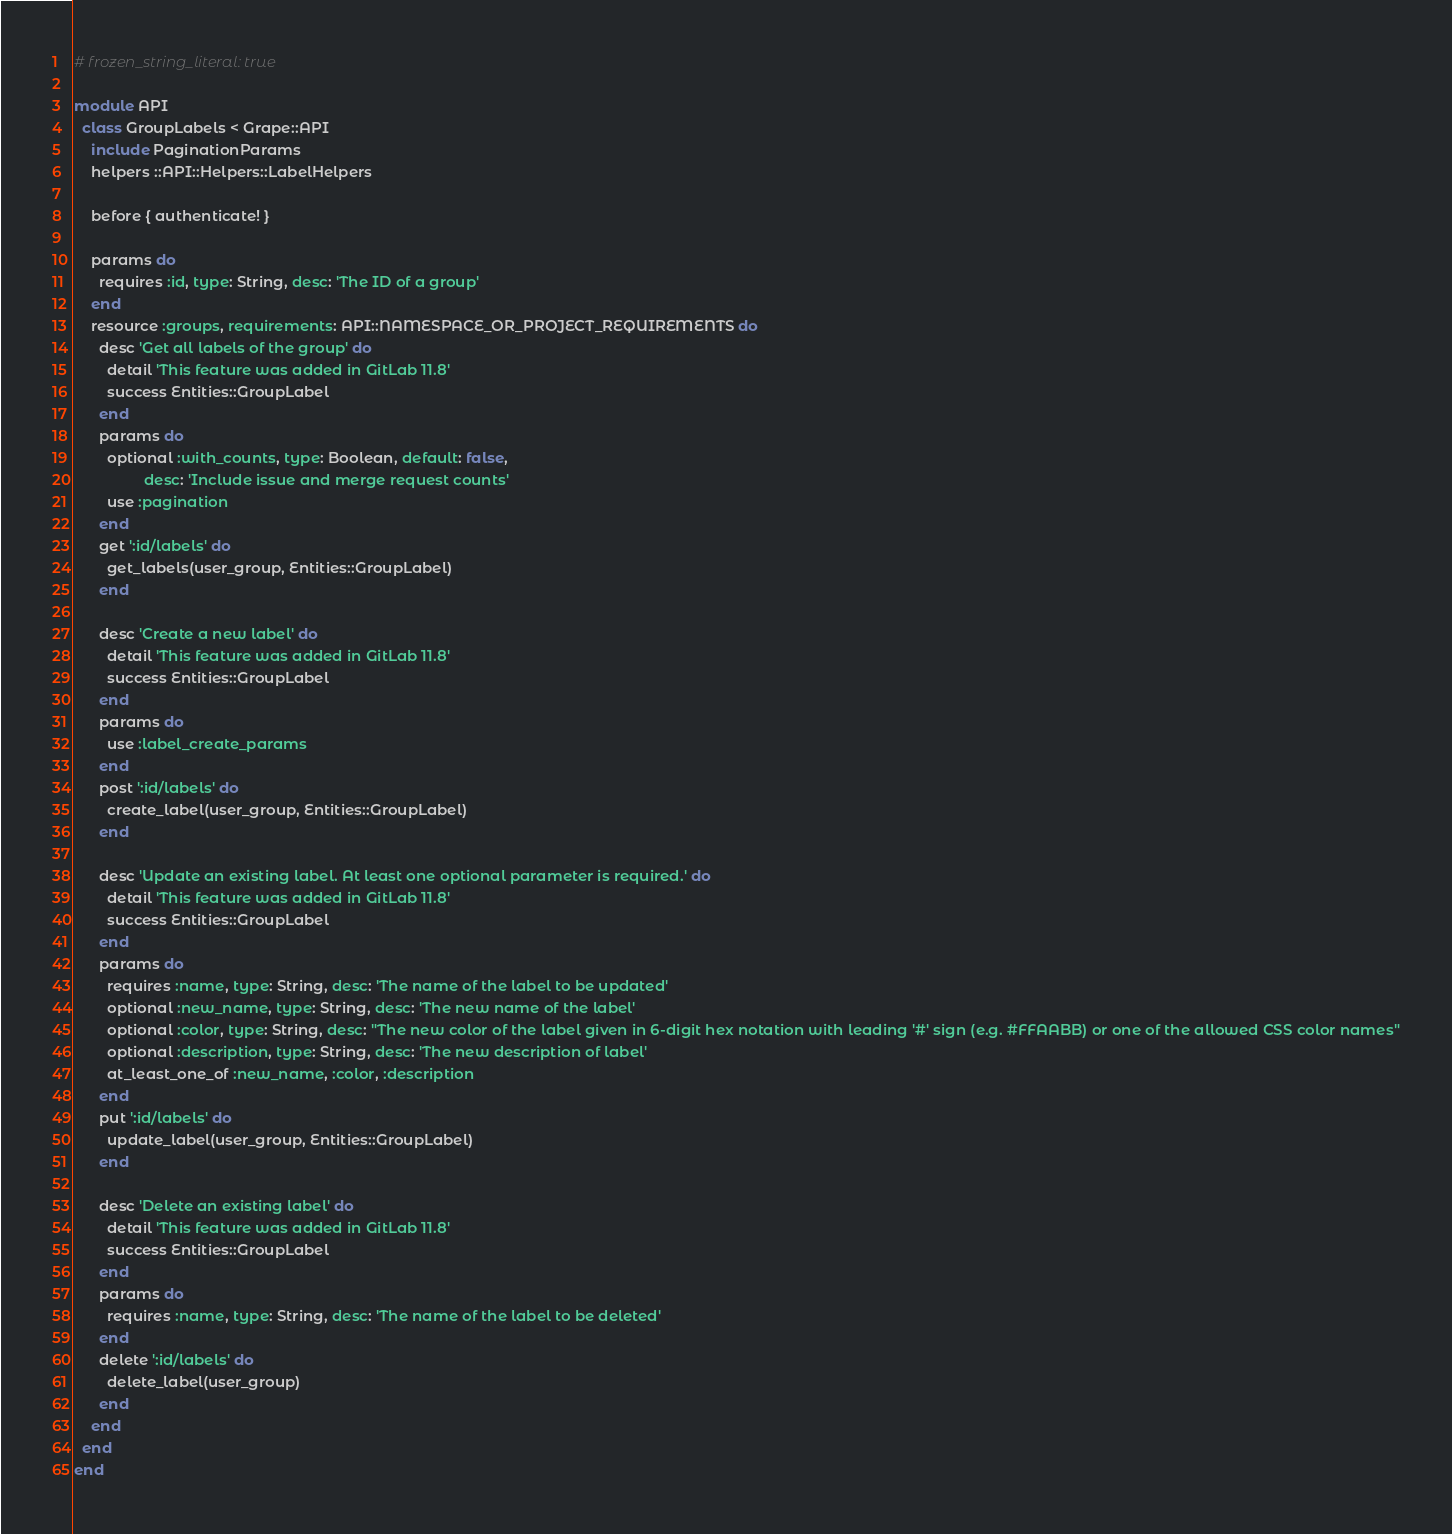<code> <loc_0><loc_0><loc_500><loc_500><_Ruby_># frozen_string_literal: true

module API
  class GroupLabels < Grape::API
    include PaginationParams
    helpers ::API::Helpers::LabelHelpers

    before { authenticate! }

    params do
      requires :id, type: String, desc: 'The ID of a group'
    end
    resource :groups, requirements: API::NAMESPACE_OR_PROJECT_REQUIREMENTS do
      desc 'Get all labels of the group' do
        detail 'This feature was added in GitLab 11.8'
        success Entities::GroupLabel
      end
      params do
        optional :with_counts, type: Boolean, default: false,
                 desc: 'Include issue and merge request counts'
        use :pagination
      end
      get ':id/labels' do
        get_labels(user_group, Entities::GroupLabel)
      end

      desc 'Create a new label' do
        detail 'This feature was added in GitLab 11.8'
        success Entities::GroupLabel
      end
      params do
        use :label_create_params
      end
      post ':id/labels' do
        create_label(user_group, Entities::GroupLabel)
      end

      desc 'Update an existing label. At least one optional parameter is required.' do
        detail 'This feature was added in GitLab 11.8'
        success Entities::GroupLabel
      end
      params do
        requires :name, type: String, desc: 'The name of the label to be updated'
        optional :new_name, type: String, desc: 'The new name of the label'
        optional :color, type: String, desc: "The new color of the label given in 6-digit hex notation with leading '#' sign (e.g. #FFAABB) or one of the allowed CSS color names"
        optional :description, type: String, desc: 'The new description of label'
        at_least_one_of :new_name, :color, :description
      end
      put ':id/labels' do
        update_label(user_group, Entities::GroupLabel)
      end

      desc 'Delete an existing label' do
        detail 'This feature was added in GitLab 11.8'
        success Entities::GroupLabel
      end
      params do
        requires :name, type: String, desc: 'The name of the label to be deleted'
      end
      delete ':id/labels' do
        delete_label(user_group)
      end
    end
  end
end
</code> 